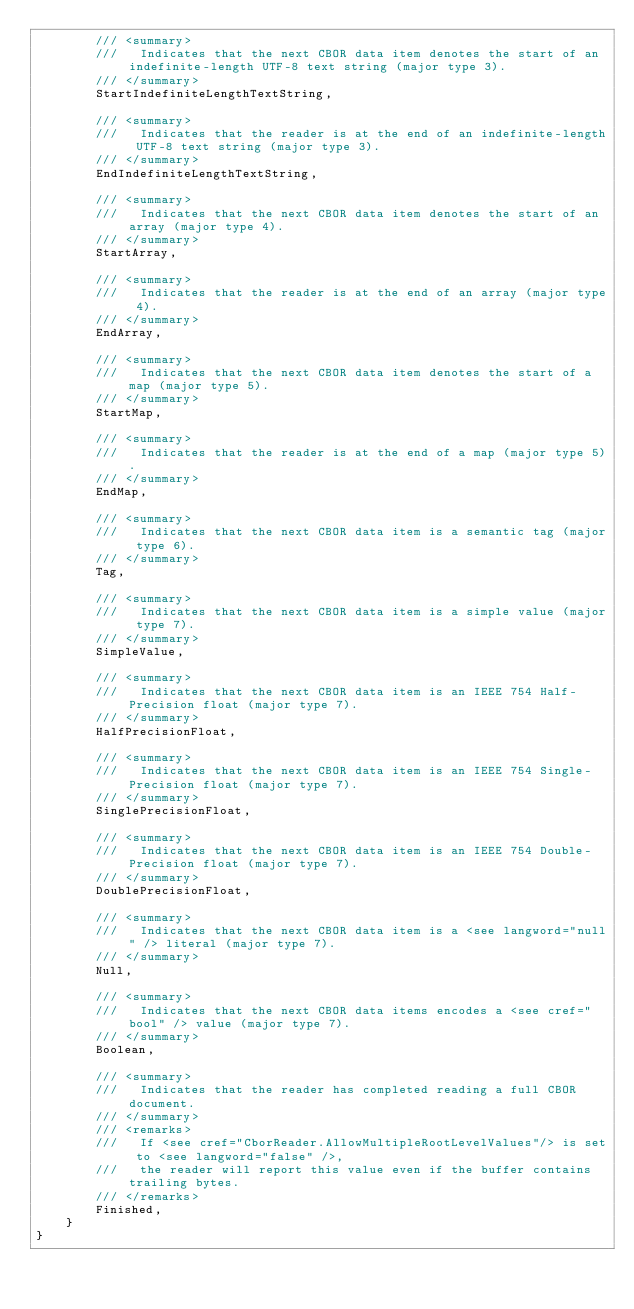<code> <loc_0><loc_0><loc_500><loc_500><_C#_>        /// <summary>
        ///   Indicates that the next CBOR data item denotes the start of an indefinite-length UTF-8 text string (major type 3).
        /// </summary>
        StartIndefiniteLengthTextString,

        /// <summary>
        ///   Indicates that the reader is at the end of an indefinite-length UTF-8 text string (major type 3).
        /// </summary>
        EndIndefiniteLengthTextString,

        /// <summary>
        ///   Indicates that the next CBOR data item denotes the start of an array (major type 4).
        /// </summary>
        StartArray,

        /// <summary>
        ///   Indicates that the reader is at the end of an array (major type 4).
        /// </summary>
        EndArray,

        /// <summary>
        ///   Indicates that the next CBOR data item denotes the start of a map (major type 5).
        /// </summary>
        StartMap,

        /// <summary>
        ///   Indicates that the reader is at the end of a map (major type 5).
        /// </summary>
        EndMap,

        /// <summary>
        ///   Indicates that the next CBOR data item is a semantic tag (major type 6).
        /// </summary>
        Tag,

        /// <summary>
        ///   Indicates that the next CBOR data item is a simple value (major type 7).
        /// </summary>
        SimpleValue,

        /// <summary>
        ///   Indicates that the next CBOR data item is an IEEE 754 Half-Precision float (major type 7).
        /// </summary>
        HalfPrecisionFloat,

        /// <summary>
        ///   Indicates that the next CBOR data item is an IEEE 754 Single-Precision float (major type 7).
        /// </summary>
        SinglePrecisionFloat,

        /// <summary>
        ///   Indicates that the next CBOR data item is an IEEE 754 Double-Precision float (major type 7).
        /// </summary>
        DoublePrecisionFloat,

        /// <summary>
        ///   Indicates that the next CBOR data item is a <see langword="null" /> literal (major type 7).
        /// </summary>
        Null,

        /// <summary>
        ///   Indicates that the next CBOR data items encodes a <see cref="bool" /> value (major type 7).
        /// </summary>
        Boolean,

        /// <summary>
        ///   Indicates that the reader has completed reading a full CBOR document.
        /// </summary>
        /// <remarks>
        ///   If <see cref="CborReader.AllowMultipleRootLevelValues"/> is set to <see langword="false" />,
        ///   the reader will report this value even if the buffer contains trailing bytes.
        /// </remarks>
        Finished,
    }
}
</code> 